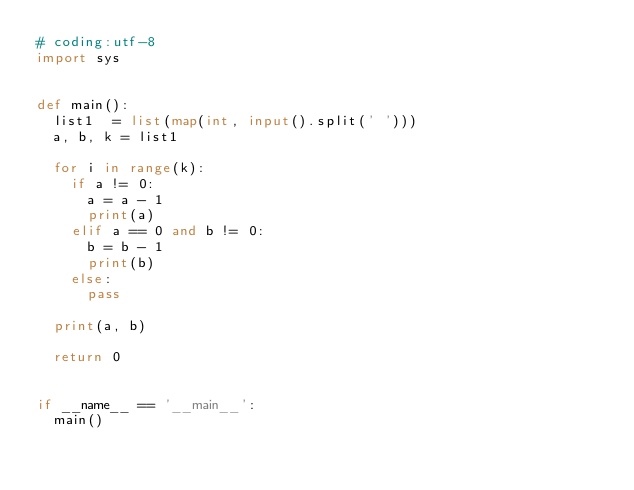<code> <loc_0><loc_0><loc_500><loc_500><_Python_># coding:utf-8
import sys


def main():
  list1  = list(map(int, input().split(' '))) 
  a, b, k = list1
  
  for i in range(k):
    if a != 0:
      a = a - 1
      print(a)
    elif a == 0 and b != 0:
      b = b - 1
      print(b)
    else:
      pass
    
  print(a, b)
  
  return 0


if __name__ == '__main__':
  main()</code> 